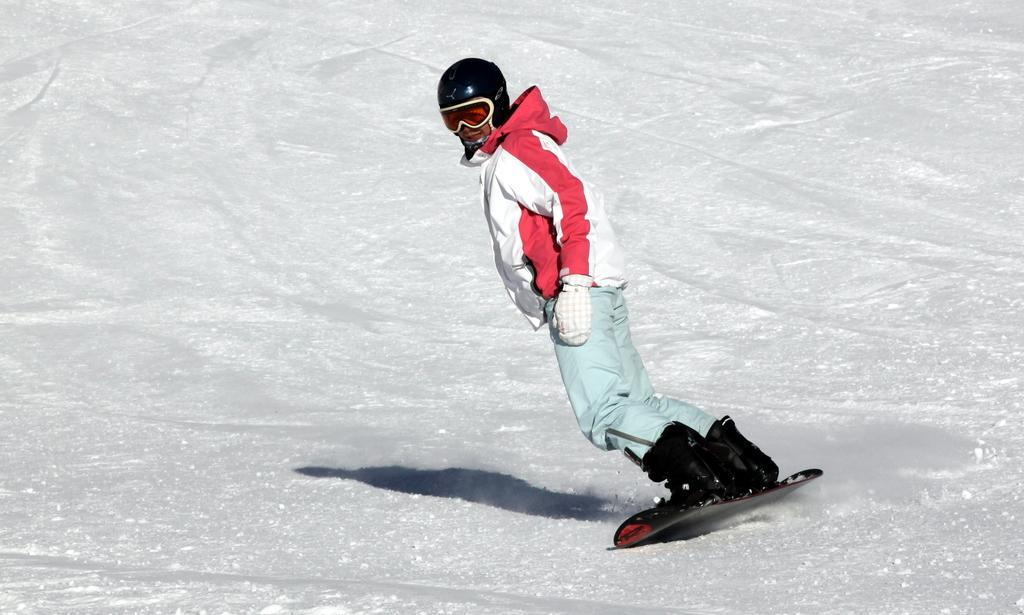What is the main subject of the image? There is a person in the image. What type of protective gear is the person wearing? The person is wearing a helmet. What type of clothing is the person wearing? The person is wearing a jacket, pants, and shoes. What activity is the person engaged in? The person is skiing on the snow. What type of leaf can be seen falling from the sky in the image? There are no leaves present in the image, as it depicts a person skiing on the snow. Is the person's partner visible in the image? There is no mention of a partner in the image, and only one person is depicted. 